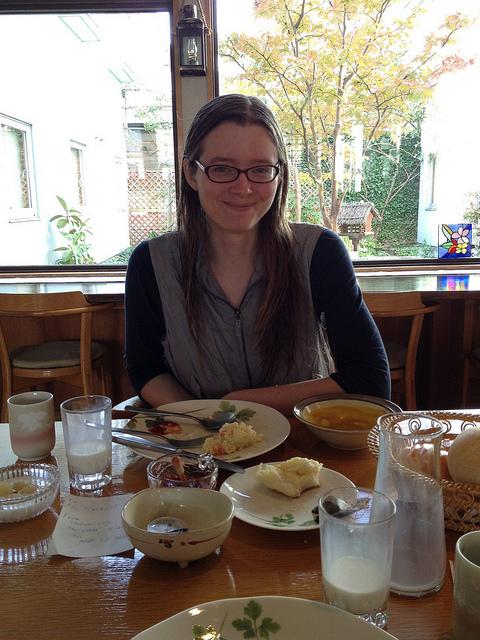How many cups are on the girls right?
Give a very brief answer. 2. What's in the backyard?
Be succinct. Trees. Is that a donut or a bagel?
Keep it brief. Neither. Is there milk?
Write a very short answer. Yes. 